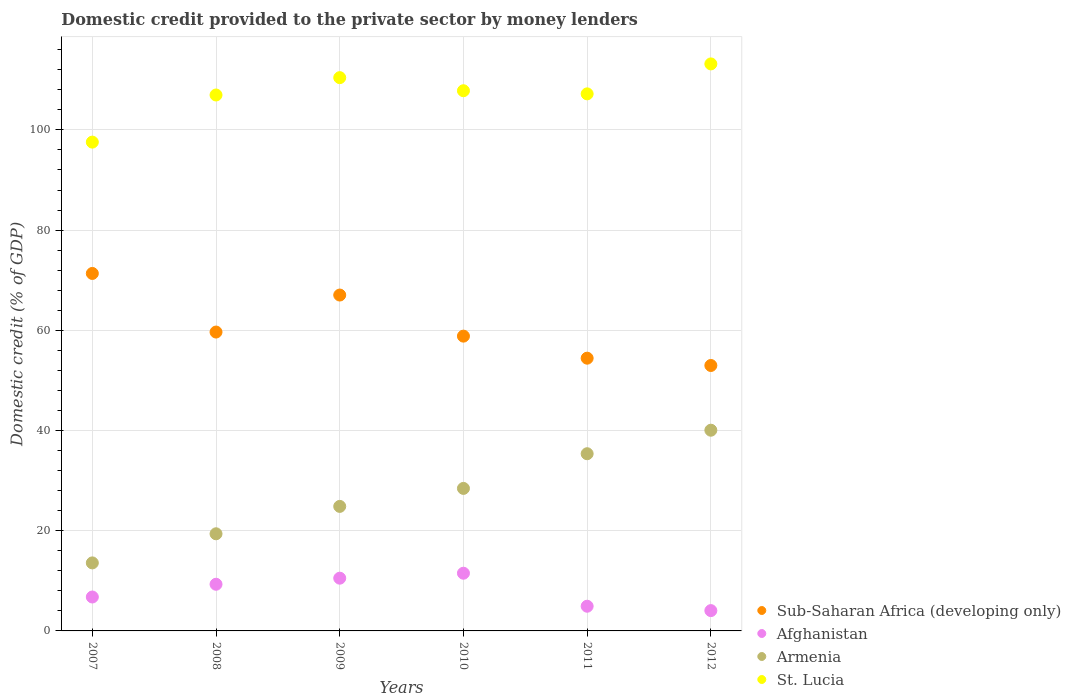Is the number of dotlines equal to the number of legend labels?
Provide a short and direct response. Yes. What is the domestic credit provided to the private sector by money lenders in Afghanistan in 2008?
Your answer should be very brief. 9.31. Across all years, what is the maximum domestic credit provided to the private sector by money lenders in St. Lucia?
Your answer should be compact. 113.17. Across all years, what is the minimum domestic credit provided to the private sector by money lenders in Armenia?
Your response must be concise. 13.58. In which year was the domestic credit provided to the private sector by money lenders in St. Lucia minimum?
Provide a short and direct response. 2007. What is the total domestic credit provided to the private sector by money lenders in Sub-Saharan Africa (developing only) in the graph?
Provide a short and direct response. 364.3. What is the difference between the domestic credit provided to the private sector by money lenders in Sub-Saharan Africa (developing only) in 2010 and that in 2012?
Make the answer very short. 5.86. What is the difference between the domestic credit provided to the private sector by money lenders in St. Lucia in 2011 and the domestic credit provided to the private sector by money lenders in Armenia in 2010?
Keep it short and to the point. 78.75. What is the average domestic credit provided to the private sector by money lenders in Afghanistan per year?
Your answer should be compact. 7.85. In the year 2011, what is the difference between the domestic credit provided to the private sector by money lenders in St. Lucia and domestic credit provided to the private sector by money lenders in Armenia?
Ensure brevity in your answer.  71.83. In how many years, is the domestic credit provided to the private sector by money lenders in St. Lucia greater than 44 %?
Provide a succinct answer. 6. What is the ratio of the domestic credit provided to the private sector by money lenders in Armenia in 2007 to that in 2012?
Provide a succinct answer. 0.34. Is the domestic credit provided to the private sector by money lenders in St. Lucia in 2007 less than that in 2011?
Give a very brief answer. Yes. What is the difference between the highest and the second highest domestic credit provided to the private sector by money lenders in St. Lucia?
Keep it short and to the point. 2.74. What is the difference between the highest and the lowest domestic credit provided to the private sector by money lenders in Sub-Saharan Africa (developing only)?
Keep it short and to the point. 18.37. In how many years, is the domestic credit provided to the private sector by money lenders in St. Lucia greater than the average domestic credit provided to the private sector by money lenders in St. Lucia taken over all years?
Your answer should be very brief. 4. Is it the case that in every year, the sum of the domestic credit provided to the private sector by money lenders in Armenia and domestic credit provided to the private sector by money lenders in St. Lucia  is greater than the sum of domestic credit provided to the private sector by money lenders in Afghanistan and domestic credit provided to the private sector by money lenders in Sub-Saharan Africa (developing only)?
Provide a short and direct response. Yes. Is it the case that in every year, the sum of the domestic credit provided to the private sector by money lenders in Sub-Saharan Africa (developing only) and domestic credit provided to the private sector by money lenders in Afghanistan  is greater than the domestic credit provided to the private sector by money lenders in Armenia?
Your answer should be very brief. Yes. Is the domestic credit provided to the private sector by money lenders in St. Lucia strictly greater than the domestic credit provided to the private sector by money lenders in Armenia over the years?
Give a very brief answer. Yes. Is the domestic credit provided to the private sector by money lenders in St. Lucia strictly less than the domestic credit provided to the private sector by money lenders in Armenia over the years?
Your answer should be compact. No. How many dotlines are there?
Provide a short and direct response. 4. What is the difference between two consecutive major ticks on the Y-axis?
Give a very brief answer. 20. Are the values on the major ticks of Y-axis written in scientific E-notation?
Offer a terse response. No. Where does the legend appear in the graph?
Ensure brevity in your answer.  Bottom right. What is the title of the graph?
Your response must be concise. Domestic credit provided to the private sector by money lenders. Does "Namibia" appear as one of the legend labels in the graph?
Ensure brevity in your answer.  No. What is the label or title of the Y-axis?
Ensure brevity in your answer.  Domestic credit (% of GDP). What is the Domestic credit (% of GDP) in Sub-Saharan Africa (developing only) in 2007?
Your answer should be compact. 71.35. What is the Domestic credit (% of GDP) in Afghanistan in 2007?
Your response must be concise. 6.77. What is the Domestic credit (% of GDP) in Armenia in 2007?
Give a very brief answer. 13.58. What is the Domestic credit (% of GDP) of St. Lucia in 2007?
Your response must be concise. 97.56. What is the Domestic credit (% of GDP) of Sub-Saharan Africa (developing only) in 2008?
Provide a succinct answer. 59.65. What is the Domestic credit (% of GDP) of Afghanistan in 2008?
Keep it short and to the point. 9.31. What is the Domestic credit (% of GDP) in Armenia in 2008?
Your answer should be compact. 19.39. What is the Domestic credit (% of GDP) in St. Lucia in 2008?
Offer a terse response. 106.97. What is the Domestic credit (% of GDP) of Sub-Saharan Africa (developing only) in 2009?
Your answer should be very brief. 67.04. What is the Domestic credit (% of GDP) in Afghanistan in 2009?
Your answer should be compact. 10.53. What is the Domestic credit (% of GDP) of Armenia in 2009?
Ensure brevity in your answer.  24.85. What is the Domestic credit (% of GDP) of St. Lucia in 2009?
Your answer should be very brief. 110.43. What is the Domestic credit (% of GDP) in Sub-Saharan Africa (developing only) in 2010?
Ensure brevity in your answer.  58.84. What is the Domestic credit (% of GDP) in Afghanistan in 2010?
Your answer should be compact. 11.52. What is the Domestic credit (% of GDP) in Armenia in 2010?
Your answer should be very brief. 28.45. What is the Domestic credit (% of GDP) of St. Lucia in 2010?
Your answer should be compact. 107.82. What is the Domestic credit (% of GDP) of Sub-Saharan Africa (developing only) in 2011?
Ensure brevity in your answer.  54.44. What is the Domestic credit (% of GDP) in Afghanistan in 2011?
Your answer should be compact. 4.93. What is the Domestic credit (% of GDP) in Armenia in 2011?
Your answer should be very brief. 35.37. What is the Domestic credit (% of GDP) of St. Lucia in 2011?
Your answer should be very brief. 107.19. What is the Domestic credit (% of GDP) in Sub-Saharan Africa (developing only) in 2012?
Keep it short and to the point. 52.98. What is the Domestic credit (% of GDP) of Afghanistan in 2012?
Provide a short and direct response. 4.05. What is the Domestic credit (% of GDP) of Armenia in 2012?
Give a very brief answer. 40.06. What is the Domestic credit (% of GDP) in St. Lucia in 2012?
Your response must be concise. 113.17. Across all years, what is the maximum Domestic credit (% of GDP) in Sub-Saharan Africa (developing only)?
Offer a terse response. 71.35. Across all years, what is the maximum Domestic credit (% of GDP) in Afghanistan?
Your answer should be compact. 11.52. Across all years, what is the maximum Domestic credit (% of GDP) in Armenia?
Ensure brevity in your answer.  40.06. Across all years, what is the maximum Domestic credit (% of GDP) in St. Lucia?
Keep it short and to the point. 113.17. Across all years, what is the minimum Domestic credit (% of GDP) of Sub-Saharan Africa (developing only)?
Your answer should be very brief. 52.98. Across all years, what is the minimum Domestic credit (% of GDP) in Afghanistan?
Give a very brief answer. 4.05. Across all years, what is the minimum Domestic credit (% of GDP) in Armenia?
Provide a short and direct response. 13.58. Across all years, what is the minimum Domestic credit (% of GDP) of St. Lucia?
Your response must be concise. 97.56. What is the total Domestic credit (% of GDP) of Sub-Saharan Africa (developing only) in the graph?
Give a very brief answer. 364.3. What is the total Domestic credit (% of GDP) of Afghanistan in the graph?
Your answer should be very brief. 47.11. What is the total Domestic credit (% of GDP) of Armenia in the graph?
Your answer should be very brief. 161.69. What is the total Domestic credit (% of GDP) of St. Lucia in the graph?
Your answer should be very brief. 643.15. What is the difference between the Domestic credit (% of GDP) of Sub-Saharan Africa (developing only) in 2007 and that in 2008?
Your response must be concise. 11.7. What is the difference between the Domestic credit (% of GDP) of Afghanistan in 2007 and that in 2008?
Provide a succinct answer. -2.54. What is the difference between the Domestic credit (% of GDP) in Armenia in 2007 and that in 2008?
Your response must be concise. -5.81. What is the difference between the Domestic credit (% of GDP) in St. Lucia in 2007 and that in 2008?
Offer a terse response. -9.41. What is the difference between the Domestic credit (% of GDP) of Sub-Saharan Africa (developing only) in 2007 and that in 2009?
Make the answer very short. 4.31. What is the difference between the Domestic credit (% of GDP) of Afghanistan in 2007 and that in 2009?
Ensure brevity in your answer.  -3.76. What is the difference between the Domestic credit (% of GDP) in Armenia in 2007 and that in 2009?
Offer a terse response. -11.28. What is the difference between the Domestic credit (% of GDP) in St. Lucia in 2007 and that in 2009?
Offer a very short reply. -12.87. What is the difference between the Domestic credit (% of GDP) of Sub-Saharan Africa (developing only) in 2007 and that in 2010?
Give a very brief answer. 12.51. What is the difference between the Domestic credit (% of GDP) in Afghanistan in 2007 and that in 2010?
Your answer should be very brief. -4.75. What is the difference between the Domestic credit (% of GDP) in Armenia in 2007 and that in 2010?
Keep it short and to the point. -14.87. What is the difference between the Domestic credit (% of GDP) in St. Lucia in 2007 and that in 2010?
Your answer should be very brief. -10.26. What is the difference between the Domestic credit (% of GDP) of Sub-Saharan Africa (developing only) in 2007 and that in 2011?
Give a very brief answer. 16.91. What is the difference between the Domestic credit (% of GDP) of Afghanistan in 2007 and that in 2011?
Keep it short and to the point. 1.84. What is the difference between the Domestic credit (% of GDP) in Armenia in 2007 and that in 2011?
Your answer should be compact. -21.79. What is the difference between the Domestic credit (% of GDP) in St. Lucia in 2007 and that in 2011?
Ensure brevity in your answer.  -9.63. What is the difference between the Domestic credit (% of GDP) in Sub-Saharan Africa (developing only) in 2007 and that in 2012?
Your answer should be very brief. 18.37. What is the difference between the Domestic credit (% of GDP) of Afghanistan in 2007 and that in 2012?
Provide a succinct answer. 2.72. What is the difference between the Domestic credit (% of GDP) in Armenia in 2007 and that in 2012?
Your answer should be compact. -26.48. What is the difference between the Domestic credit (% of GDP) of St. Lucia in 2007 and that in 2012?
Ensure brevity in your answer.  -15.61. What is the difference between the Domestic credit (% of GDP) in Sub-Saharan Africa (developing only) in 2008 and that in 2009?
Your answer should be compact. -7.39. What is the difference between the Domestic credit (% of GDP) in Afghanistan in 2008 and that in 2009?
Offer a terse response. -1.21. What is the difference between the Domestic credit (% of GDP) in Armenia in 2008 and that in 2009?
Offer a terse response. -5.47. What is the difference between the Domestic credit (% of GDP) in St. Lucia in 2008 and that in 2009?
Provide a succinct answer. -3.46. What is the difference between the Domestic credit (% of GDP) in Sub-Saharan Africa (developing only) in 2008 and that in 2010?
Give a very brief answer. 0.82. What is the difference between the Domestic credit (% of GDP) in Afghanistan in 2008 and that in 2010?
Provide a succinct answer. -2.2. What is the difference between the Domestic credit (% of GDP) in Armenia in 2008 and that in 2010?
Keep it short and to the point. -9.06. What is the difference between the Domestic credit (% of GDP) of St. Lucia in 2008 and that in 2010?
Give a very brief answer. -0.85. What is the difference between the Domestic credit (% of GDP) of Sub-Saharan Africa (developing only) in 2008 and that in 2011?
Ensure brevity in your answer.  5.22. What is the difference between the Domestic credit (% of GDP) of Afghanistan in 2008 and that in 2011?
Provide a succinct answer. 4.38. What is the difference between the Domestic credit (% of GDP) in Armenia in 2008 and that in 2011?
Provide a short and direct response. -15.98. What is the difference between the Domestic credit (% of GDP) of St. Lucia in 2008 and that in 2011?
Keep it short and to the point. -0.23. What is the difference between the Domestic credit (% of GDP) of Sub-Saharan Africa (developing only) in 2008 and that in 2012?
Provide a succinct answer. 6.67. What is the difference between the Domestic credit (% of GDP) in Afghanistan in 2008 and that in 2012?
Your response must be concise. 5.26. What is the difference between the Domestic credit (% of GDP) of Armenia in 2008 and that in 2012?
Make the answer very short. -20.67. What is the difference between the Domestic credit (% of GDP) of St. Lucia in 2008 and that in 2012?
Make the answer very short. -6.2. What is the difference between the Domestic credit (% of GDP) in Sub-Saharan Africa (developing only) in 2009 and that in 2010?
Ensure brevity in your answer.  8.2. What is the difference between the Domestic credit (% of GDP) in Afghanistan in 2009 and that in 2010?
Give a very brief answer. -0.99. What is the difference between the Domestic credit (% of GDP) in Armenia in 2009 and that in 2010?
Keep it short and to the point. -3.59. What is the difference between the Domestic credit (% of GDP) in St. Lucia in 2009 and that in 2010?
Offer a very short reply. 2.61. What is the difference between the Domestic credit (% of GDP) in Sub-Saharan Africa (developing only) in 2009 and that in 2011?
Your response must be concise. 12.6. What is the difference between the Domestic credit (% of GDP) of Afghanistan in 2009 and that in 2011?
Your answer should be very brief. 5.6. What is the difference between the Domestic credit (% of GDP) in Armenia in 2009 and that in 2011?
Your answer should be very brief. -10.51. What is the difference between the Domestic credit (% of GDP) in St. Lucia in 2009 and that in 2011?
Your answer should be compact. 3.24. What is the difference between the Domestic credit (% of GDP) in Sub-Saharan Africa (developing only) in 2009 and that in 2012?
Ensure brevity in your answer.  14.06. What is the difference between the Domestic credit (% of GDP) of Afghanistan in 2009 and that in 2012?
Ensure brevity in your answer.  6.47. What is the difference between the Domestic credit (% of GDP) of Armenia in 2009 and that in 2012?
Offer a very short reply. -15.21. What is the difference between the Domestic credit (% of GDP) of St. Lucia in 2009 and that in 2012?
Ensure brevity in your answer.  -2.74. What is the difference between the Domestic credit (% of GDP) in Sub-Saharan Africa (developing only) in 2010 and that in 2011?
Give a very brief answer. 4.4. What is the difference between the Domestic credit (% of GDP) in Afghanistan in 2010 and that in 2011?
Ensure brevity in your answer.  6.59. What is the difference between the Domestic credit (% of GDP) of Armenia in 2010 and that in 2011?
Your answer should be very brief. -6.92. What is the difference between the Domestic credit (% of GDP) of St. Lucia in 2010 and that in 2011?
Keep it short and to the point. 0.62. What is the difference between the Domestic credit (% of GDP) in Sub-Saharan Africa (developing only) in 2010 and that in 2012?
Provide a short and direct response. 5.86. What is the difference between the Domestic credit (% of GDP) in Afghanistan in 2010 and that in 2012?
Provide a short and direct response. 7.46. What is the difference between the Domestic credit (% of GDP) of Armenia in 2010 and that in 2012?
Make the answer very short. -11.61. What is the difference between the Domestic credit (% of GDP) of St. Lucia in 2010 and that in 2012?
Your answer should be compact. -5.35. What is the difference between the Domestic credit (% of GDP) in Sub-Saharan Africa (developing only) in 2011 and that in 2012?
Give a very brief answer. 1.46. What is the difference between the Domestic credit (% of GDP) of Afghanistan in 2011 and that in 2012?
Provide a short and direct response. 0.88. What is the difference between the Domestic credit (% of GDP) of Armenia in 2011 and that in 2012?
Make the answer very short. -4.69. What is the difference between the Domestic credit (% of GDP) of St. Lucia in 2011 and that in 2012?
Your answer should be very brief. -5.98. What is the difference between the Domestic credit (% of GDP) of Sub-Saharan Africa (developing only) in 2007 and the Domestic credit (% of GDP) of Afghanistan in 2008?
Provide a succinct answer. 62.04. What is the difference between the Domestic credit (% of GDP) of Sub-Saharan Africa (developing only) in 2007 and the Domestic credit (% of GDP) of Armenia in 2008?
Your response must be concise. 51.96. What is the difference between the Domestic credit (% of GDP) in Sub-Saharan Africa (developing only) in 2007 and the Domestic credit (% of GDP) in St. Lucia in 2008?
Offer a very short reply. -35.62. What is the difference between the Domestic credit (% of GDP) in Afghanistan in 2007 and the Domestic credit (% of GDP) in Armenia in 2008?
Provide a short and direct response. -12.62. What is the difference between the Domestic credit (% of GDP) in Afghanistan in 2007 and the Domestic credit (% of GDP) in St. Lucia in 2008?
Offer a very short reply. -100.2. What is the difference between the Domestic credit (% of GDP) in Armenia in 2007 and the Domestic credit (% of GDP) in St. Lucia in 2008?
Provide a short and direct response. -93.39. What is the difference between the Domestic credit (% of GDP) of Sub-Saharan Africa (developing only) in 2007 and the Domestic credit (% of GDP) of Afghanistan in 2009?
Offer a very short reply. 60.82. What is the difference between the Domestic credit (% of GDP) in Sub-Saharan Africa (developing only) in 2007 and the Domestic credit (% of GDP) in Armenia in 2009?
Give a very brief answer. 46.5. What is the difference between the Domestic credit (% of GDP) of Sub-Saharan Africa (developing only) in 2007 and the Domestic credit (% of GDP) of St. Lucia in 2009?
Your answer should be compact. -39.08. What is the difference between the Domestic credit (% of GDP) in Afghanistan in 2007 and the Domestic credit (% of GDP) in Armenia in 2009?
Keep it short and to the point. -18.08. What is the difference between the Domestic credit (% of GDP) of Afghanistan in 2007 and the Domestic credit (% of GDP) of St. Lucia in 2009?
Offer a very short reply. -103.66. What is the difference between the Domestic credit (% of GDP) in Armenia in 2007 and the Domestic credit (% of GDP) in St. Lucia in 2009?
Your answer should be very brief. -96.85. What is the difference between the Domestic credit (% of GDP) in Sub-Saharan Africa (developing only) in 2007 and the Domestic credit (% of GDP) in Afghanistan in 2010?
Your answer should be compact. 59.83. What is the difference between the Domestic credit (% of GDP) in Sub-Saharan Africa (developing only) in 2007 and the Domestic credit (% of GDP) in Armenia in 2010?
Your answer should be compact. 42.91. What is the difference between the Domestic credit (% of GDP) of Sub-Saharan Africa (developing only) in 2007 and the Domestic credit (% of GDP) of St. Lucia in 2010?
Offer a very short reply. -36.47. What is the difference between the Domestic credit (% of GDP) in Afghanistan in 2007 and the Domestic credit (% of GDP) in Armenia in 2010?
Offer a terse response. -21.67. What is the difference between the Domestic credit (% of GDP) in Afghanistan in 2007 and the Domestic credit (% of GDP) in St. Lucia in 2010?
Keep it short and to the point. -101.05. What is the difference between the Domestic credit (% of GDP) of Armenia in 2007 and the Domestic credit (% of GDP) of St. Lucia in 2010?
Keep it short and to the point. -94.24. What is the difference between the Domestic credit (% of GDP) of Sub-Saharan Africa (developing only) in 2007 and the Domestic credit (% of GDP) of Afghanistan in 2011?
Make the answer very short. 66.42. What is the difference between the Domestic credit (% of GDP) of Sub-Saharan Africa (developing only) in 2007 and the Domestic credit (% of GDP) of Armenia in 2011?
Provide a short and direct response. 35.98. What is the difference between the Domestic credit (% of GDP) of Sub-Saharan Africa (developing only) in 2007 and the Domestic credit (% of GDP) of St. Lucia in 2011?
Provide a succinct answer. -35.84. What is the difference between the Domestic credit (% of GDP) in Afghanistan in 2007 and the Domestic credit (% of GDP) in Armenia in 2011?
Your answer should be very brief. -28.6. What is the difference between the Domestic credit (% of GDP) in Afghanistan in 2007 and the Domestic credit (% of GDP) in St. Lucia in 2011?
Your answer should be very brief. -100.42. What is the difference between the Domestic credit (% of GDP) of Armenia in 2007 and the Domestic credit (% of GDP) of St. Lucia in 2011?
Your answer should be compact. -93.62. What is the difference between the Domestic credit (% of GDP) of Sub-Saharan Africa (developing only) in 2007 and the Domestic credit (% of GDP) of Afghanistan in 2012?
Give a very brief answer. 67.3. What is the difference between the Domestic credit (% of GDP) in Sub-Saharan Africa (developing only) in 2007 and the Domestic credit (% of GDP) in Armenia in 2012?
Give a very brief answer. 31.29. What is the difference between the Domestic credit (% of GDP) in Sub-Saharan Africa (developing only) in 2007 and the Domestic credit (% of GDP) in St. Lucia in 2012?
Give a very brief answer. -41.82. What is the difference between the Domestic credit (% of GDP) in Afghanistan in 2007 and the Domestic credit (% of GDP) in Armenia in 2012?
Your answer should be compact. -33.29. What is the difference between the Domestic credit (% of GDP) of Afghanistan in 2007 and the Domestic credit (% of GDP) of St. Lucia in 2012?
Your answer should be very brief. -106.4. What is the difference between the Domestic credit (% of GDP) of Armenia in 2007 and the Domestic credit (% of GDP) of St. Lucia in 2012?
Provide a short and direct response. -99.6. What is the difference between the Domestic credit (% of GDP) of Sub-Saharan Africa (developing only) in 2008 and the Domestic credit (% of GDP) of Afghanistan in 2009?
Provide a succinct answer. 49.13. What is the difference between the Domestic credit (% of GDP) in Sub-Saharan Africa (developing only) in 2008 and the Domestic credit (% of GDP) in Armenia in 2009?
Provide a short and direct response. 34.8. What is the difference between the Domestic credit (% of GDP) in Sub-Saharan Africa (developing only) in 2008 and the Domestic credit (% of GDP) in St. Lucia in 2009?
Ensure brevity in your answer.  -50.78. What is the difference between the Domestic credit (% of GDP) of Afghanistan in 2008 and the Domestic credit (% of GDP) of Armenia in 2009?
Your answer should be compact. -15.54. What is the difference between the Domestic credit (% of GDP) of Afghanistan in 2008 and the Domestic credit (% of GDP) of St. Lucia in 2009?
Offer a terse response. -101.12. What is the difference between the Domestic credit (% of GDP) in Armenia in 2008 and the Domestic credit (% of GDP) in St. Lucia in 2009?
Your response must be concise. -91.04. What is the difference between the Domestic credit (% of GDP) in Sub-Saharan Africa (developing only) in 2008 and the Domestic credit (% of GDP) in Afghanistan in 2010?
Give a very brief answer. 48.14. What is the difference between the Domestic credit (% of GDP) of Sub-Saharan Africa (developing only) in 2008 and the Domestic credit (% of GDP) of Armenia in 2010?
Your response must be concise. 31.21. What is the difference between the Domestic credit (% of GDP) in Sub-Saharan Africa (developing only) in 2008 and the Domestic credit (% of GDP) in St. Lucia in 2010?
Ensure brevity in your answer.  -48.17. What is the difference between the Domestic credit (% of GDP) in Afghanistan in 2008 and the Domestic credit (% of GDP) in Armenia in 2010?
Provide a short and direct response. -19.13. What is the difference between the Domestic credit (% of GDP) in Afghanistan in 2008 and the Domestic credit (% of GDP) in St. Lucia in 2010?
Offer a terse response. -98.51. What is the difference between the Domestic credit (% of GDP) of Armenia in 2008 and the Domestic credit (% of GDP) of St. Lucia in 2010?
Make the answer very short. -88.43. What is the difference between the Domestic credit (% of GDP) of Sub-Saharan Africa (developing only) in 2008 and the Domestic credit (% of GDP) of Afghanistan in 2011?
Provide a short and direct response. 54.72. What is the difference between the Domestic credit (% of GDP) of Sub-Saharan Africa (developing only) in 2008 and the Domestic credit (% of GDP) of Armenia in 2011?
Keep it short and to the point. 24.29. What is the difference between the Domestic credit (% of GDP) of Sub-Saharan Africa (developing only) in 2008 and the Domestic credit (% of GDP) of St. Lucia in 2011?
Your response must be concise. -47.54. What is the difference between the Domestic credit (% of GDP) in Afghanistan in 2008 and the Domestic credit (% of GDP) in Armenia in 2011?
Your answer should be compact. -26.05. What is the difference between the Domestic credit (% of GDP) of Afghanistan in 2008 and the Domestic credit (% of GDP) of St. Lucia in 2011?
Your answer should be compact. -97.88. What is the difference between the Domestic credit (% of GDP) of Armenia in 2008 and the Domestic credit (% of GDP) of St. Lucia in 2011?
Ensure brevity in your answer.  -87.81. What is the difference between the Domestic credit (% of GDP) in Sub-Saharan Africa (developing only) in 2008 and the Domestic credit (% of GDP) in Afghanistan in 2012?
Offer a very short reply. 55.6. What is the difference between the Domestic credit (% of GDP) of Sub-Saharan Africa (developing only) in 2008 and the Domestic credit (% of GDP) of Armenia in 2012?
Your answer should be compact. 19.59. What is the difference between the Domestic credit (% of GDP) in Sub-Saharan Africa (developing only) in 2008 and the Domestic credit (% of GDP) in St. Lucia in 2012?
Your answer should be compact. -53.52. What is the difference between the Domestic credit (% of GDP) of Afghanistan in 2008 and the Domestic credit (% of GDP) of Armenia in 2012?
Provide a short and direct response. -30.75. What is the difference between the Domestic credit (% of GDP) in Afghanistan in 2008 and the Domestic credit (% of GDP) in St. Lucia in 2012?
Provide a succinct answer. -103.86. What is the difference between the Domestic credit (% of GDP) in Armenia in 2008 and the Domestic credit (% of GDP) in St. Lucia in 2012?
Make the answer very short. -93.79. What is the difference between the Domestic credit (% of GDP) of Sub-Saharan Africa (developing only) in 2009 and the Domestic credit (% of GDP) of Afghanistan in 2010?
Offer a very short reply. 55.52. What is the difference between the Domestic credit (% of GDP) in Sub-Saharan Africa (developing only) in 2009 and the Domestic credit (% of GDP) in Armenia in 2010?
Provide a short and direct response. 38.59. What is the difference between the Domestic credit (% of GDP) of Sub-Saharan Africa (developing only) in 2009 and the Domestic credit (% of GDP) of St. Lucia in 2010?
Your response must be concise. -40.78. What is the difference between the Domestic credit (% of GDP) of Afghanistan in 2009 and the Domestic credit (% of GDP) of Armenia in 2010?
Make the answer very short. -17.92. What is the difference between the Domestic credit (% of GDP) of Afghanistan in 2009 and the Domestic credit (% of GDP) of St. Lucia in 2010?
Make the answer very short. -97.29. What is the difference between the Domestic credit (% of GDP) in Armenia in 2009 and the Domestic credit (% of GDP) in St. Lucia in 2010?
Your answer should be compact. -82.96. What is the difference between the Domestic credit (% of GDP) of Sub-Saharan Africa (developing only) in 2009 and the Domestic credit (% of GDP) of Afghanistan in 2011?
Provide a succinct answer. 62.11. What is the difference between the Domestic credit (% of GDP) in Sub-Saharan Africa (developing only) in 2009 and the Domestic credit (% of GDP) in Armenia in 2011?
Provide a short and direct response. 31.67. What is the difference between the Domestic credit (% of GDP) in Sub-Saharan Africa (developing only) in 2009 and the Domestic credit (% of GDP) in St. Lucia in 2011?
Your response must be concise. -40.16. What is the difference between the Domestic credit (% of GDP) of Afghanistan in 2009 and the Domestic credit (% of GDP) of Armenia in 2011?
Offer a very short reply. -24.84. What is the difference between the Domestic credit (% of GDP) in Afghanistan in 2009 and the Domestic credit (% of GDP) in St. Lucia in 2011?
Give a very brief answer. -96.67. What is the difference between the Domestic credit (% of GDP) in Armenia in 2009 and the Domestic credit (% of GDP) in St. Lucia in 2011?
Ensure brevity in your answer.  -82.34. What is the difference between the Domestic credit (% of GDP) of Sub-Saharan Africa (developing only) in 2009 and the Domestic credit (% of GDP) of Afghanistan in 2012?
Your answer should be compact. 62.99. What is the difference between the Domestic credit (% of GDP) in Sub-Saharan Africa (developing only) in 2009 and the Domestic credit (% of GDP) in Armenia in 2012?
Offer a terse response. 26.98. What is the difference between the Domestic credit (% of GDP) in Sub-Saharan Africa (developing only) in 2009 and the Domestic credit (% of GDP) in St. Lucia in 2012?
Offer a very short reply. -46.13. What is the difference between the Domestic credit (% of GDP) in Afghanistan in 2009 and the Domestic credit (% of GDP) in Armenia in 2012?
Your answer should be very brief. -29.53. What is the difference between the Domestic credit (% of GDP) in Afghanistan in 2009 and the Domestic credit (% of GDP) in St. Lucia in 2012?
Offer a very short reply. -102.65. What is the difference between the Domestic credit (% of GDP) in Armenia in 2009 and the Domestic credit (% of GDP) in St. Lucia in 2012?
Ensure brevity in your answer.  -88.32. What is the difference between the Domestic credit (% of GDP) in Sub-Saharan Africa (developing only) in 2010 and the Domestic credit (% of GDP) in Afghanistan in 2011?
Offer a terse response. 53.91. What is the difference between the Domestic credit (% of GDP) of Sub-Saharan Africa (developing only) in 2010 and the Domestic credit (% of GDP) of Armenia in 2011?
Provide a short and direct response. 23.47. What is the difference between the Domestic credit (% of GDP) of Sub-Saharan Africa (developing only) in 2010 and the Domestic credit (% of GDP) of St. Lucia in 2011?
Provide a short and direct response. -48.36. What is the difference between the Domestic credit (% of GDP) of Afghanistan in 2010 and the Domestic credit (% of GDP) of Armenia in 2011?
Your answer should be very brief. -23.85. What is the difference between the Domestic credit (% of GDP) of Afghanistan in 2010 and the Domestic credit (% of GDP) of St. Lucia in 2011?
Your response must be concise. -95.68. What is the difference between the Domestic credit (% of GDP) in Armenia in 2010 and the Domestic credit (% of GDP) in St. Lucia in 2011?
Provide a succinct answer. -78.75. What is the difference between the Domestic credit (% of GDP) of Sub-Saharan Africa (developing only) in 2010 and the Domestic credit (% of GDP) of Afghanistan in 2012?
Your answer should be very brief. 54.78. What is the difference between the Domestic credit (% of GDP) in Sub-Saharan Africa (developing only) in 2010 and the Domestic credit (% of GDP) in Armenia in 2012?
Offer a terse response. 18.78. What is the difference between the Domestic credit (% of GDP) in Sub-Saharan Africa (developing only) in 2010 and the Domestic credit (% of GDP) in St. Lucia in 2012?
Keep it short and to the point. -54.34. What is the difference between the Domestic credit (% of GDP) of Afghanistan in 2010 and the Domestic credit (% of GDP) of Armenia in 2012?
Your answer should be very brief. -28.54. What is the difference between the Domestic credit (% of GDP) in Afghanistan in 2010 and the Domestic credit (% of GDP) in St. Lucia in 2012?
Your answer should be very brief. -101.66. What is the difference between the Domestic credit (% of GDP) in Armenia in 2010 and the Domestic credit (% of GDP) in St. Lucia in 2012?
Keep it short and to the point. -84.73. What is the difference between the Domestic credit (% of GDP) in Sub-Saharan Africa (developing only) in 2011 and the Domestic credit (% of GDP) in Afghanistan in 2012?
Your answer should be compact. 50.38. What is the difference between the Domestic credit (% of GDP) in Sub-Saharan Africa (developing only) in 2011 and the Domestic credit (% of GDP) in Armenia in 2012?
Keep it short and to the point. 14.38. What is the difference between the Domestic credit (% of GDP) of Sub-Saharan Africa (developing only) in 2011 and the Domestic credit (% of GDP) of St. Lucia in 2012?
Provide a succinct answer. -58.74. What is the difference between the Domestic credit (% of GDP) in Afghanistan in 2011 and the Domestic credit (% of GDP) in Armenia in 2012?
Your answer should be compact. -35.13. What is the difference between the Domestic credit (% of GDP) of Afghanistan in 2011 and the Domestic credit (% of GDP) of St. Lucia in 2012?
Ensure brevity in your answer.  -108.24. What is the difference between the Domestic credit (% of GDP) in Armenia in 2011 and the Domestic credit (% of GDP) in St. Lucia in 2012?
Your answer should be compact. -77.81. What is the average Domestic credit (% of GDP) of Sub-Saharan Africa (developing only) per year?
Your answer should be very brief. 60.72. What is the average Domestic credit (% of GDP) of Afghanistan per year?
Make the answer very short. 7.85. What is the average Domestic credit (% of GDP) of Armenia per year?
Keep it short and to the point. 26.95. What is the average Domestic credit (% of GDP) in St. Lucia per year?
Provide a short and direct response. 107.19. In the year 2007, what is the difference between the Domestic credit (% of GDP) in Sub-Saharan Africa (developing only) and Domestic credit (% of GDP) in Afghanistan?
Your answer should be very brief. 64.58. In the year 2007, what is the difference between the Domestic credit (% of GDP) of Sub-Saharan Africa (developing only) and Domestic credit (% of GDP) of Armenia?
Provide a succinct answer. 57.77. In the year 2007, what is the difference between the Domestic credit (% of GDP) of Sub-Saharan Africa (developing only) and Domestic credit (% of GDP) of St. Lucia?
Ensure brevity in your answer.  -26.21. In the year 2007, what is the difference between the Domestic credit (% of GDP) of Afghanistan and Domestic credit (% of GDP) of Armenia?
Offer a terse response. -6.81. In the year 2007, what is the difference between the Domestic credit (% of GDP) of Afghanistan and Domestic credit (% of GDP) of St. Lucia?
Your answer should be very brief. -90.79. In the year 2007, what is the difference between the Domestic credit (% of GDP) in Armenia and Domestic credit (% of GDP) in St. Lucia?
Offer a terse response. -83.98. In the year 2008, what is the difference between the Domestic credit (% of GDP) of Sub-Saharan Africa (developing only) and Domestic credit (% of GDP) of Afghanistan?
Your answer should be compact. 50.34. In the year 2008, what is the difference between the Domestic credit (% of GDP) in Sub-Saharan Africa (developing only) and Domestic credit (% of GDP) in Armenia?
Your answer should be very brief. 40.27. In the year 2008, what is the difference between the Domestic credit (% of GDP) in Sub-Saharan Africa (developing only) and Domestic credit (% of GDP) in St. Lucia?
Ensure brevity in your answer.  -47.31. In the year 2008, what is the difference between the Domestic credit (% of GDP) of Afghanistan and Domestic credit (% of GDP) of Armenia?
Offer a terse response. -10.07. In the year 2008, what is the difference between the Domestic credit (% of GDP) of Afghanistan and Domestic credit (% of GDP) of St. Lucia?
Provide a short and direct response. -97.65. In the year 2008, what is the difference between the Domestic credit (% of GDP) in Armenia and Domestic credit (% of GDP) in St. Lucia?
Provide a succinct answer. -87.58. In the year 2009, what is the difference between the Domestic credit (% of GDP) of Sub-Saharan Africa (developing only) and Domestic credit (% of GDP) of Afghanistan?
Make the answer very short. 56.51. In the year 2009, what is the difference between the Domestic credit (% of GDP) in Sub-Saharan Africa (developing only) and Domestic credit (% of GDP) in Armenia?
Keep it short and to the point. 42.18. In the year 2009, what is the difference between the Domestic credit (% of GDP) of Sub-Saharan Africa (developing only) and Domestic credit (% of GDP) of St. Lucia?
Make the answer very short. -43.39. In the year 2009, what is the difference between the Domestic credit (% of GDP) in Afghanistan and Domestic credit (% of GDP) in Armenia?
Provide a short and direct response. -14.33. In the year 2009, what is the difference between the Domestic credit (% of GDP) in Afghanistan and Domestic credit (% of GDP) in St. Lucia?
Provide a short and direct response. -99.91. In the year 2009, what is the difference between the Domestic credit (% of GDP) of Armenia and Domestic credit (% of GDP) of St. Lucia?
Your answer should be very brief. -85.58. In the year 2010, what is the difference between the Domestic credit (% of GDP) in Sub-Saharan Africa (developing only) and Domestic credit (% of GDP) in Afghanistan?
Ensure brevity in your answer.  47.32. In the year 2010, what is the difference between the Domestic credit (% of GDP) of Sub-Saharan Africa (developing only) and Domestic credit (% of GDP) of Armenia?
Your answer should be very brief. 30.39. In the year 2010, what is the difference between the Domestic credit (% of GDP) in Sub-Saharan Africa (developing only) and Domestic credit (% of GDP) in St. Lucia?
Keep it short and to the point. -48.98. In the year 2010, what is the difference between the Domestic credit (% of GDP) of Afghanistan and Domestic credit (% of GDP) of Armenia?
Your response must be concise. -16.93. In the year 2010, what is the difference between the Domestic credit (% of GDP) of Afghanistan and Domestic credit (% of GDP) of St. Lucia?
Provide a short and direct response. -96.3. In the year 2010, what is the difference between the Domestic credit (% of GDP) in Armenia and Domestic credit (% of GDP) in St. Lucia?
Ensure brevity in your answer.  -79.37. In the year 2011, what is the difference between the Domestic credit (% of GDP) in Sub-Saharan Africa (developing only) and Domestic credit (% of GDP) in Afghanistan?
Offer a very short reply. 49.51. In the year 2011, what is the difference between the Domestic credit (% of GDP) in Sub-Saharan Africa (developing only) and Domestic credit (% of GDP) in Armenia?
Make the answer very short. 19.07. In the year 2011, what is the difference between the Domestic credit (% of GDP) in Sub-Saharan Africa (developing only) and Domestic credit (% of GDP) in St. Lucia?
Ensure brevity in your answer.  -52.76. In the year 2011, what is the difference between the Domestic credit (% of GDP) of Afghanistan and Domestic credit (% of GDP) of Armenia?
Your response must be concise. -30.44. In the year 2011, what is the difference between the Domestic credit (% of GDP) of Afghanistan and Domestic credit (% of GDP) of St. Lucia?
Your answer should be very brief. -102.27. In the year 2011, what is the difference between the Domestic credit (% of GDP) of Armenia and Domestic credit (% of GDP) of St. Lucia?
Offer a terse response. -71.83. In the year 2012, what is the difference between the Domestic credit (% of GDP) of Sub-Saharan Africa (developing only) and Domestic credit (% of GDP) of Afghanistan?
Provide a succinct answer. 48.93. In the year 2012, what is the difference between the Domestic credit (% of GDP) of Sub-Saharan Africa (developing only) and Domestic credit (% of GDP) of Armenia?
Your answer should be compact. 12.92. In the year 2012, what is the difference between the Domestic credit (% of GDP) in Sub-Saharan Africa (developing only) and Domestic credit (% of GDP) in St. Lucia?
Keep it short and to the point. -60.19. In the year 2012, what is the difference between the Domestic credit (% of GDP) in Afghanistan and Domestic credit (% of GDP) in Armenia?
Ensure brevity in your answer.  -36.01. In the year 2012, what is the difference between the Domestic credit (% of GDP) in Afghanistan and Domestic credit (% of GDP) in St. Lucia?
Provide a succinct answer. -109.12. In the year 2012, what is the difference between the Domestic credit (% of GDP) of Armenia and Domestic credit (% of GDP) of St. Lucia?
Provide a short and direct response. -73.11. What is the ratio of the Domestic credit (% of GDP) in Sub-Saharan Africa (developing only) in 2007 to that in 2008?
Provide a short and direct response. 1.2. What is the ratio of the Domestic credit (% of GDP) of Afghanistan in 2007 to that in 2008?
Provide a succinct answer. 0.73. What is the ratio of the Domestic credit (% of GDP) in Armenia in 2007 to that in 2008?
Your answer should be compact. 0.7. What is the ratio of the Domestic credit (% of GDP) of St. Lucia in 2007 to that in 2008?
Provide a short and direct response. 0.91. What is the ratio of the Domestic credit (% of GDP) of Sub-Saharan Africa (developing only) in 2007 to that in 2009?
Give a very brief answer. 1.06. What is the ratio of the Domestic credit (% of GDP) in Afghanistan in 2007 to that in 2009?
Offer a very short reply. 0.64. What is the ratio of the Domestic credit (% of GDP) in Armenia in 2007 to that in 2009?
Make the answer very short. 0.55. What is the ratio of the Domestic credit (% of GDP) of St. Lucia in 2007 to that in 2009?
Provide a succinct answer. 0.88. What is the ratio of the Domestic credit (% of GDP) in Sub-Saharan Africa (developing only) in 2007 to that in 2010?
Your response must be concise. 1.21. What is the ratio of the Domestic credit (% of GDP) of Afghanistan in 2007 to that in 2010?
Offer a terse response. 0.59. What is the ratio of the Domestic credit (% of GDP) of Armenia in 2007 to that in 2010?
Offer a terse response. 0.48. What is the ratio of the Domestic credit (% of GDP) in St. Lucia in 2007 to that in 2010?
Your answer should be very brief. 0.9. What is the ratio of the Domestic credit (% of GDP) of Sub-Saharan Africa (developing only) in 2007 to that in 2011?
Ensure brevity in your answer.  1.31. What is the ratio of the Domestic credit (% of GDP) in Afghanistan in 2007 to that in 2011?
Provide a short and direct response. 1.37. What is the ratio of the Domestic credit (% of GDP) of Armenia in 2007 to that in 2011?
Offer a terse response. 0.38. What is the ratio of the Domestic credit (% of GDP) in St. Lucia in 2007 to that in 2011?
Make the answer very short. 0.91. What is the ratio of the Domestic credit (% of GDP) in Sub-Saharan Africa (developing only) in 2007 to that in 2012?
Offer a very short reply. 1.35. What is the ratio of the Domestic credit (% of GDP) in Afghanistan in 2007 to that in 2012?
Keep it short and to the point. 1.67. What is the ratio of the Domestic credit (% of GDP) in Armenia in 2007 to that in 2012?
Ensure brevity in your answer.  0.34. What is the ratio of the Domestic credit (% of GDP) in St. Lucia in 2007 to that in 2012?
Provide a short and direct response. 0.86. What is the ratio of the Domestic credit (% of GDP) in Sub-Saharan Africa (developing only) in 2008 to that in 2009?
Your answer should be compact. 0.89. What is the ratio of the Domestic credit (% of GDP) in Afghanistan in 2008 to that in 2009?
Offer a very short reply. 0.88. What is the ratio of the Domestic credit (% of GDP) of Armenia in 2008 to that in 2009?
Give a very brief answer. 0.78. What is the ratio of the Domestic credit (% of GDP) in St. Lucia in 2008 to that in 2009?
Keep it short and to the point. 0.97. What is the ratio of the Domestic credit (% of GDP) of Sub-Saharan Africa (developing only) in 2008 to that in 2010?
Ensure brevity in your answer.  1.01. What is the ratio of the Domestic credit (% of GDP) in Afghanistan in 2008 to that in 2010?
Make the answer very short. 0.81. What is the ratio of the Domestic credit (% of GDP) of Armenia in 2008 to that in 2010?
Make the answer very short. 0.68. What is the ratio of the Domestic credit (% of GDP) of Sub-Saharan Africa (developing only) in 2008 to that in 2011?
Provide a short and direct response. 1.1. What is the ratio of the Domestic credit (% of GDP) in Afghanistan in 2008 to that in 2011?
Provide a succinct answer. 1.89. What is the ratio of the Domestic credit (% of GDP) of Armenia in 2008 to that in 2011?
Provide a succinct answer. 0.55. What is the ratio of the Domestic credit (% of GDP) of Sub-Saharan Africa (developing only) in 2008 to that in 2012?
Give a very brief answer. 1.13. What is the ratio of the Domestic credit (% of GDP) in Afghanistan in 2008 to that in 2012?
Provide a succinct answer. 2.3. What is the ratio of the Domestic credit (% of GDP) in Armenia in 2008 to that in 2012?
Provide a succinct answer. 0.48. What is the ratio of the Domestic credit (% of GDP) in St. Lucia in 2008 to that in 2012?
Offer a terse response. 0.95. What is the ratio of the Domestic credit (% of GDP) of Sub-Saharan Africa (developing only) in 2009 to that in 2010?
Make the answer very short. 1.14. What is the ratio of the Domestic credit (% of GDP) in Afghanistan in 2009 to that in 2010?
Make the answer very short. 0.91. What is the ratio of the Domestic credit (% of GDP) of Armenia in 2009 to that in 2010?
Make the answer very short. 0.87. What is the ratio of the Domestic credit (% of GDP) of St. Lucia in 2009 to that in 2010?
Provide a short and direct response. 1.02. What is the ratio of the Domestic credit (% of GDP) of Sub-Saharan Africa (developing only) in 2009 to that in 2011?
Provide a succinct answer. 1.23. What is the ratio of the Domestic credit (% of GDP) of Afghanistan in 2009 to that in 2011?
Offer a terse response. 2.14. What is the ratio of the Domestic credit (% of GDP) in Armenia in 2009 to that in 2011?
Provide a succinct answer. 0.7. What is the ratio of the Domestic credit (% of GDP) of St. Lucia in 2009 to that in 2011?
Your answer should be very brief. 1.03. What is the ratio of the Domestic credit (% of GDP) in Sub-Saharan Africa (developing only) in 2009 to that in 2012?
Your response must be concise. 1.27. What is the ratio of the Domestic credit (% of GDP) in Afghanistan in 2009 to that in 2012?
Your answer should be very brief. 2.6. What is the ratio of the Domestic credit (% of GDP) in Armenia in 2009 to that in 2012?
Offer a terse response. 0.62. What is the ratio of the Domestic credit (% of GDP) in St. Lucia in 2009 to that in 2012?
Offer a very short reply. 0.98. What is the ratio of the Domestic credit (% of GDP) in Sub-Saharan Africa (developing only) in 2010 to that in 2011?
Your answer should be very brief. 1.08. What is the ratio of the Domestic credit (% of GDP) in Afghanistan in 2010 to that in 2011?
Your answer should be compact. 2.34. What is the ratio of the Domestic credit (% of GDP) of Armenia in 2010 to that in 2011?
Provide a succinct answer. 0.8. What is the ratio of the Domestic credit (% of GDP) in Sub-Saharan Africa (developing only) in 2010 to that in 2012?
Your response must be concise. 1.11. What is the ratio of the Domestic credit (% of GDP) in Afghanistan in 2010 to that in 2012?
Give a very brief answer. 2.84. What is the ratio of the Domestic credit (% of GDP) in Armenia in 2010 to that in 2012?
Your response must be concise. 0.71. What is the ratio of the Domestic credit (% of GDP) of St. Lucia in 2010 to that in 2012?
Offer a terse response. 0.95. What is the ratio of the Domestic credit (% of GDP) in Sub-Saharan Africa (developing only) in 2011 to that in 2012?
Give a very brief answer. 1.03. What is the ratio of the Domestic credit (% of GDP) in Afghanistan in 2011 to that in 2012?
Your answer should be very brief. 1.22. What is the ratio of the Domestic credit (% of GDP) in Armenia in 2011 to that in 2012?
Give a very brief answer. 0.88. What is the ratio of the Domestic credit (% of GDP) of St. Lucia in 2011 to that in 2012?
Your response must be concise. 0.95. What is the difference between the highest and the second highest Domestic credit (% of GDP) in Sub-Saharan Africa (developing only)?
Offer a terse response. 4.31. What is the difference between the highest and the second highest Domestic credit (% of GDP) in Afghanistan?
Give a very brief answer. 0.99. What is the difference between the highest and the second highest Domestic credit (% of GDP) in Armenia?
Give a very brief answer. 4.69. What is the difference between the highest and the second highest Domestic credit (% of GDP) of St. Lucia?
Keep it short and to the point. 2.74. What is the difference between the highest and the lowest Domestic credit (% of GDP) in Sub-Saharan Africa (developing only)?
Provide a succinct answer. 18.37. What is the difference between the highest and the lowest Domestic credit (% of GDP) in Afghanistan?
Provide a short and direct response. 7.46. What is the difference between the highest and the lowest Domestic credit (% of GDP) of Armenia?
Offer a terse response. 26.48. What is the difference between the highest and the lowest Domestic credit (% of GDP) in St. Lucia?
Provide a succinct answer. 15.61. 